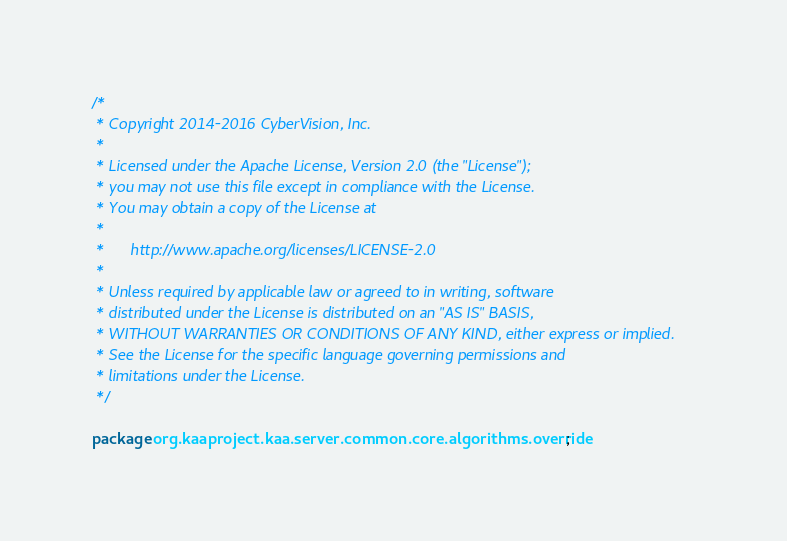<code> <loc_0><loc_0><loc_500><loc_500><_Java_>/*
 * Copyright 2014-2016 CyberVision, Inc.
 *
 * Licensed under the Apache License, Version 2.0 (the "License");
 * you may not use this file except in compliance with the License.
 * You may obtain a copy of the License at
 *
 *      http://www.apache.org/licenses/LICENSE-2.0
 *
 * Unless required by applicable law or agreed to in writing, software
 * distributed under the License is distributed on an "AS IS" BASIS,
 * WITHOUT WARRANTIES OR CONDITIONS OF ANY KIND, either express or implied.
 * See the License for the specific language governing permissions and
 * limitations under the License.
 */

package org.kaaproject.kaa.server.common.core.algorithms.override;
</code> 